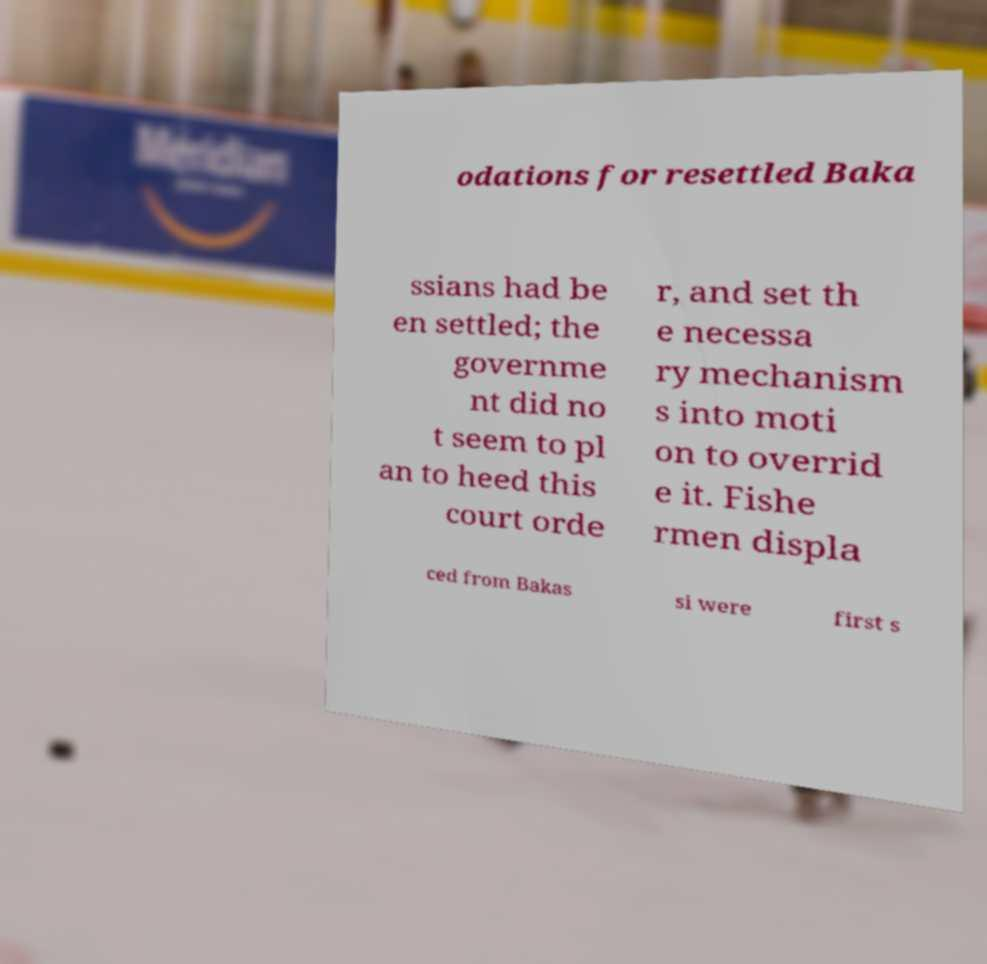There's text embedded in this image that I need extracted. Can you transcribe it verbatim? odations for resettled Baka ssians had be en settled; the governme nt did no t seem to pl an to heed this court orde r, and set th e necessa ry mechanism s into moti on to overrid e it. Fishe rmen displa ced from Bakas si were first s 